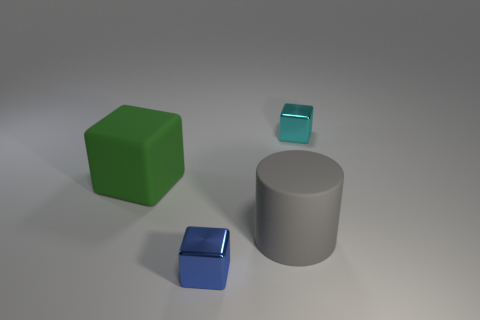Is there anything else that is the same shape as the big gray rubber thing?
Keep it short and to the point. No. What shape is the tiny metallic thing to the left of the tiny cyan metallic thing that is behind the tiny blue shiny cube?
Provide a short and direct response. Cube. There is a big rubber cylinder; what number of large green objects are to the left of it?
Offer a terse response. 1. Are there any other tiny things that have the same material as the green object?
Your response must be concise. No. There is a thing that is the same size as the gray cylinder; what is its material?
Provide a succinct answer. Rubber. What size is the cube that is behind the tiny blue block and to the right of the green rubber block?
Ensure brevity in your answer.  Small. There is a cube that is both right of the big green thing and in front of the cyan shiny object; what color is it?
Ensure brevity in your answer.  Blue. Are there fewer big matte blocks that are behind the cyan object than big gray objects to the right of the matte block?
Your answer should be compact. Yes. How many green matte things are the same shape as the blue metallic thing?
Make the answer very short. 1. The cyan block that is made of the same material as the tiny blue object is what size?
Give a very brief answer. Small. 